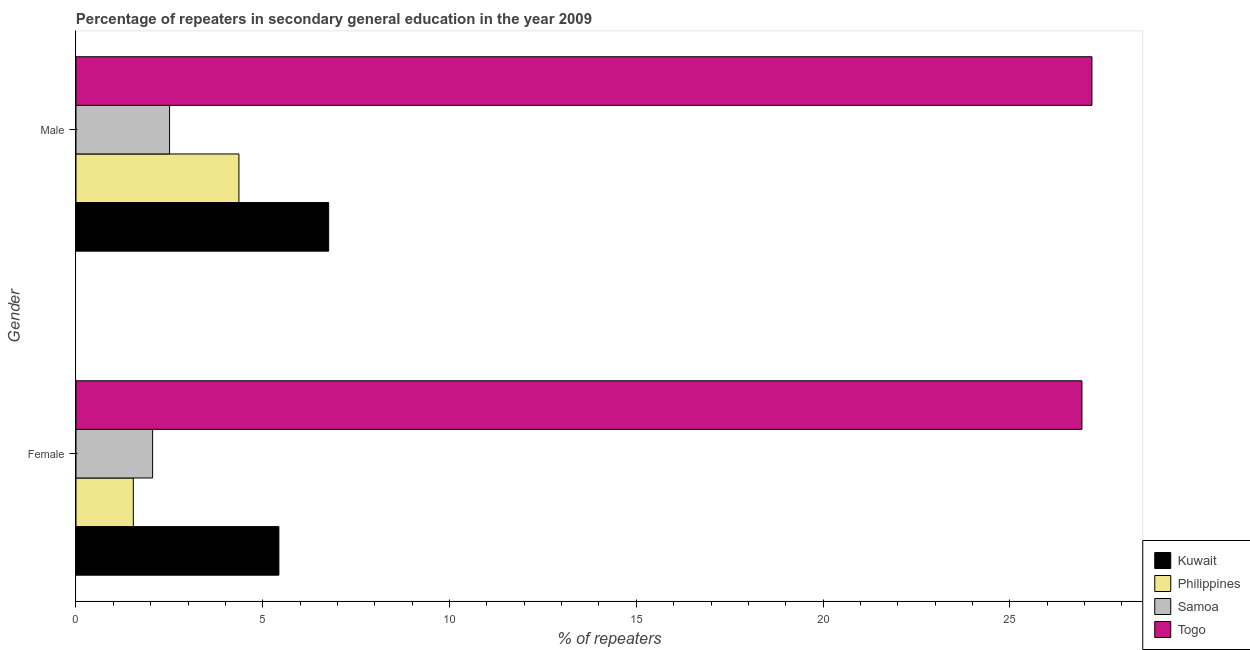Are the number of bars per tick equal to the number of legend labels?
Your response must be concise. Yes. Are the number of bars on each tick of the Y-axis equal?
Make the answer very short. Yes. What is the label of the 2nd group of bars from the top?
Ensure brevity in your answer.  Female. What is the percentage of male repeaters in Togo?
Offer a very short reply. 27.2. Across all countries, what is the maximum percentage of male repeaters?
Make the answer very short. 27.2. Across all countries, what is the minimum percentage of male repeaters?
Ensure brevity in your answer.  2.51. In which country was the percentage of female repeaters maximum?
Give a very brief answer. Togo. In which country was the percentage of female repeaters minimum?
Make the answer very short. Philippines. What is the total percentage of female repeaters in the graph?
Provide a short and direct response. 35.95. What is the difference between the percentage of female repeaters in Philippines and that in Togo?
Your response must be concise. -25.4. What is the difference between the percentage of male repeaters in Samoa and the percentage of female repeaters in Philippines?
Your answer should be compact. 0.97. What is the average percentage of male repeaters per country?
Give a very brief answer. 10.21. What is the difference between the percentage of female repeaters and percentage of male repeaters in Philippines?
Ensure brevity in your answer.  -2.83. What is the ratio of the percentage of female repeaters in Togo to that in Kuwait?
Your answer should be compact. 4.96. Is the percentage of female repeaters in Togo less than that in Samoa?
Provide a succinct answer. No. In how many countries, is the percentage of female repeaters greater than the average percentage of female repeaters taken over all countries?
Your answer should be compact. 1. What does the 2nd bar from the top in Male represents?
Give a very brief answer. Samoa. What does the 2nd bar from the bottom in Male represents?
Ensure brevity in your answer.  Philippines. How many bars are there?
Provide a succinct answer. 8. What is the difference between two consecutive major ticks on the X-axis?
Provide a succinct answer. 5. Where does the legend appear in the graph?
Keep it short and to the point. Bottom right. What is the title of the graph?
Your response must be concise. Percentage of repeaters in secondary general education in the year 2009. What is the label or title of the X-axis?
Provide a short and direct response. % of repeaters. What is the % of repeaters in Kuwait in Female?
Your response must be concise. 5.43. What is the % of repeaters in Philippines in Female?
Provide a succinct answer. 1.53. What is the % of repeaters of Samoa in Female?
Provide a short and direct response. 2.05. What is the % of repeaters in Togo in Female?
Make the answer very short. 26.93. What is the % of repeaters of Kuwait in Male?
Offer a terse response. 6.76. What is the % of repeaters of Philippines in Male?
Your answer should be very brief. 4.36. What is the % of repeaters of Samoa in Male?
Your answer should be very brief. 2.51. What is the % of repeaters in Togo in Male?
Your answer should be compact. 27.2. Across all Gender, what is the maximum % of repeaters in Kuwait?
Your response must be concise. 6.76. Across all Gender, what is the maximum % of repeaters of Philippines?
Provide a succinct answer. 4.36. Across all Gender, what is the maximum % of repeaters in Samoa?
Keep it short and to the point. 2.51. Across all Gender, what is the maximum % of repeaters of Togo?
Your response must be concise. 27.2. Across all Gender, what is the minimum % of repeaters of Kuwait?
Your answer should be very brief. 5.43. Across all Gender, what is the minimum % of repeaters of Philippines?
Provide a succinct answer. 1.53. Across all Gender, what is the minimum % of repeaters in Samoa?
Give a very brief answer. 2.05. Across all Gender, what is the minimum % of repeaters of Togo?
Your answer should be compact. 26.93. What is the total % of repeaters of Kuwait in the graph?
Give a very brief answer. 12.2. What is the total % of repeaters in Philippines in the graph?
Keep it short and to the point. 5.9. What is the total % of repeaters in Samoa in the graph?
Your answer should be very brief. 4.56. What is the total % of repeaters in Togo in the graph?
Provide a succinct answer. 54.13. What is the difference between the % of repeaters of Kuwait in Female and that in Male?
Provide a succinct answer. -1.33. What is the difference between the % of repeaters in Philippines in Female and that in Male?
Your response must be concise. -2.83. What is the difference between the % of repeaters in Samoa in Female and that in Male?
Ensure brevity in your answer.  -0.45. What is the difference between the % of repeaters of Togo in Female and that in Male?
Provide a short and direct response. -0.27. What is the difference between the % of repeaters of Kuwait in Female and the % of repeaters of Philippines in Male?
Give a very brief answer. 1.07. What is the difference between the % of repeaters of Kuwait in Female and the % of repeaters of Samoa in Male?
Your answer should be very brief. 2.93. What is the difference between the % of repeaters in Kuwait in Female and the % of repeaters in Togo in Male?
Make the answer very short. -21.77. What is the difference between the % of repeaters in Philippines in Female and the % of repeaters in Samoa in Male?
Give a very brief answer. -0.97. What is the difference between the % of repeaters of Philippines in Female and the % of repeaters of Togo in Male?
Offer a very short reply. -25.66. What is the difference between the % of repeaters of Samoa in Female and the % of repeaters of Togo in Male?
Your answer should be compact. -25.15. What is the average % of repeaters in Kuwait per Gender?
Make the answer very short. 6.1. What is the average % of repeaters in Philippines per Gender?
Provide a short and direct response. 2.95. What is the average % of repeaters in Samoa per Gender?
Ensure brevity in your answer.  2.28. What is the average % of repeaters of Togo per Gender?
Keep it short and to the point. 27.06. What is the difference between the % of repeaters of Kuwait and % of repeaters of Philippines in Female?
Provide a short and direct response. 3.9. What is the difference between the % of repeaters of Kuwait and % of repeaters of Samoa in Female?
Ensure brevity in your answer.  3.38. What is the difference between the % of repeaters of Kuwait and % of repeaters of Togo in Female?
Make the answer very short. -21.5. What is the difference between the % of repeaters of Philippines and % of repeaters of Samoa in Female?
Provide a succinct answer. -0.52. What is the difference between the % of repeaters of Philippines and % of repeaters of Togo in Female?
Make the answer very short. -25.4. What is the difference between the % of repeaters of Samoa and % of repeaters of Togo in Female?
Your answer should be very brief. -24.88. What is the difference between the % of repeaters of Kuwait and % of repeaters of Philippines in Male?
Your response must be concise. 2.4. What is the difference between the % of repeaters of Kuwait and % of repeaters of Samoa in Male?
Provide a succinct answer. 4.26. What is the difference between the % of repeaters in Kuwait and % of repeaters in Togo in Male?
Your answer should be very brief. -20.43. What is the difference between the % of repeaters in Philippines and % of repeaters in Samoa in Male?
Provide a short and direct response. 1.86. What is the difference between the % of repeaters of Philippines and % of repeaters of Togo in Male?
Give a very brief answer. -22.84. What is the difference between the % of repeaters in Samoa and % of repeaters in Togo in Male?
Offer a terse response. -24.69. What is the ratio of the % of repeaters of Kuwait in Female to that in Male?
Offer a terse response. 0.8. What is the ratio of the % of repeaters of Philippines in Female to that in Male?
Your answer should be compact. 0.35. What is the ratio of the % of repeaters in Samoa in Female to that in Male?
Your answer should be very brief. 0.82. What is the ratio of the % of repeaters in Togo in Female to that in Male?
Offer a very short reply. 0.99. What is the difference between the highest and the second highest % of repeaters of Kuwait?
Make the answer very short. 1.33. What is the difference between the highest and the second highest % of repeaters in Philippines?
Give a very brief answer. 2.83. What is the difference between the highest and the second highest % of repeaters of Samoa?
Your answer should be compact. 0.45. What is the difference between the highest and the second highest % of repeaters in Togo?
Keep it short and to the point. 0.27. What is the difference between the highest and the lowest % of repeaters of Kuwait?
Offer a terse response. 1.33. What is the difference between the highest and the lowest % of repeaters in Philippines?
Give a very brief answer. 2.83. What is the difference between the highest and the lowest % of repeaters in Samoa?
Offer a very short reply. 0.45. What is the difference between the highest and the lowest % of repeaters in Togo?
Provide a succinct answer. 0.27. 